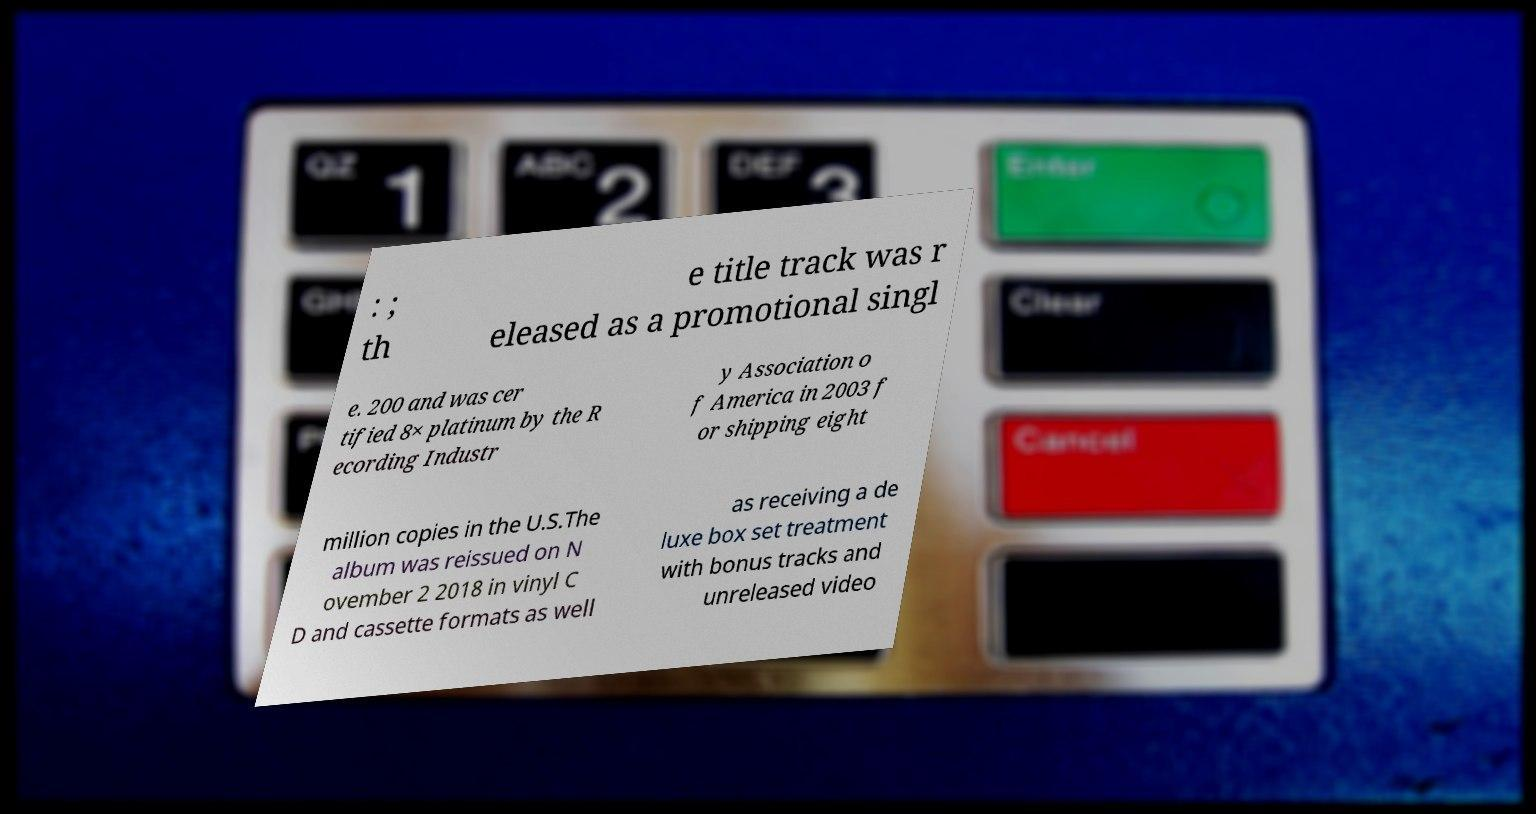I need the written content from this picture converted into text. Can you do that? : ; th e title track was r eleased as a promotional singl e. 200 and was cer tified 8× platinum by the R ecording Industr y Association o f America in 2003 f or shipping eight million copies in the U.S.The album was reissued on N ovember 2 2018 in vinyl C D and cassette formats as well as receiving a de luxe box set treatment with bonus tracks and unreleased video 